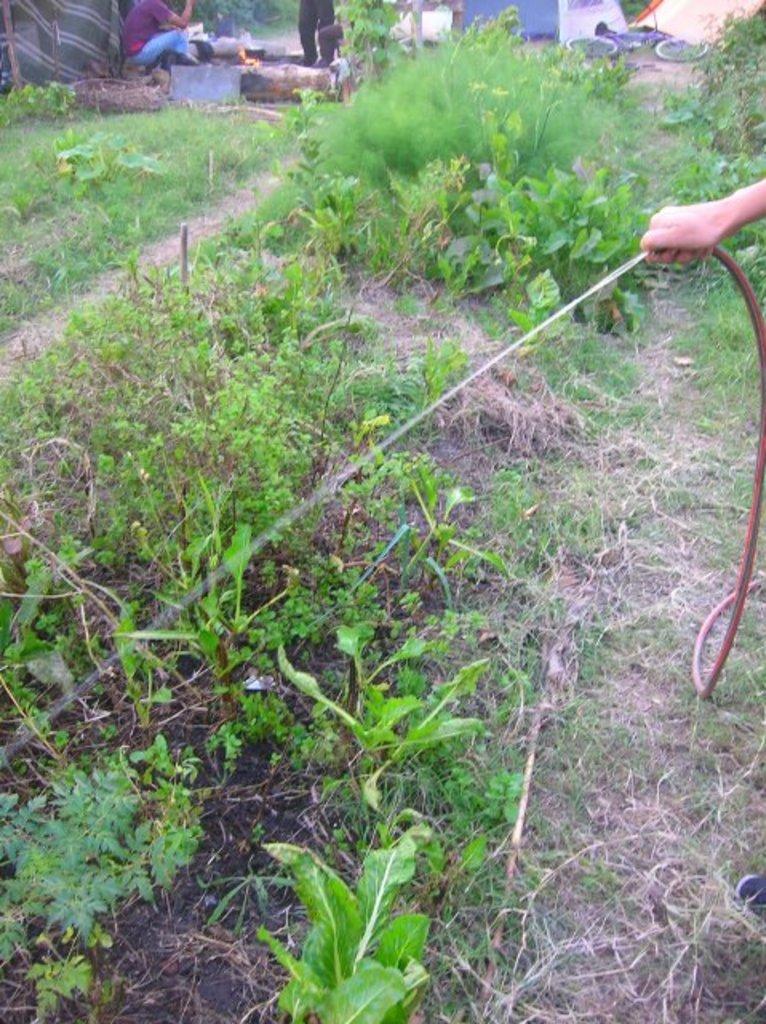Can you describe this image briefly? In the foreground of this image, there are plants and the grass and a persons holding a pipe and watering the plants. In the background, there are persons, fire, a cloth, bicycle lying on the ground and it seems like a wall on the top. 